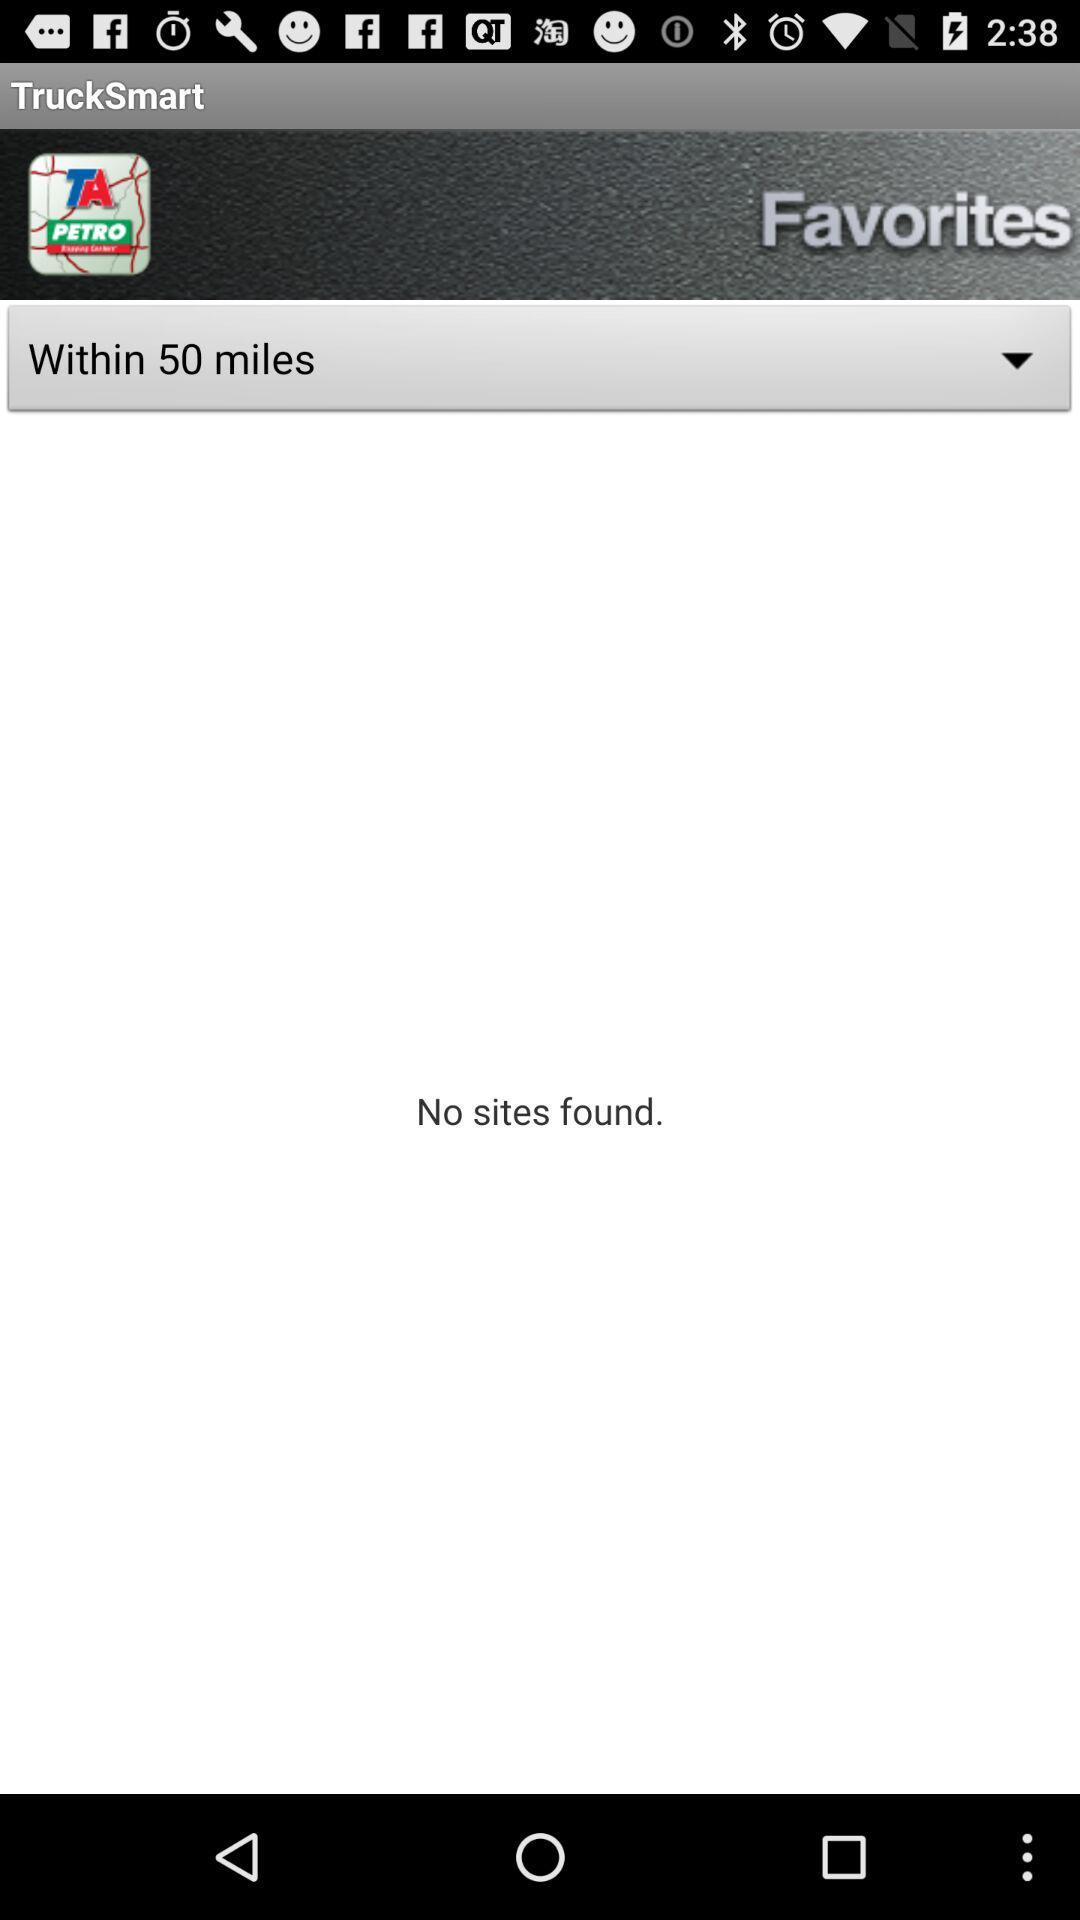What is the given distance in miles? The given distance in miles is within 50. 